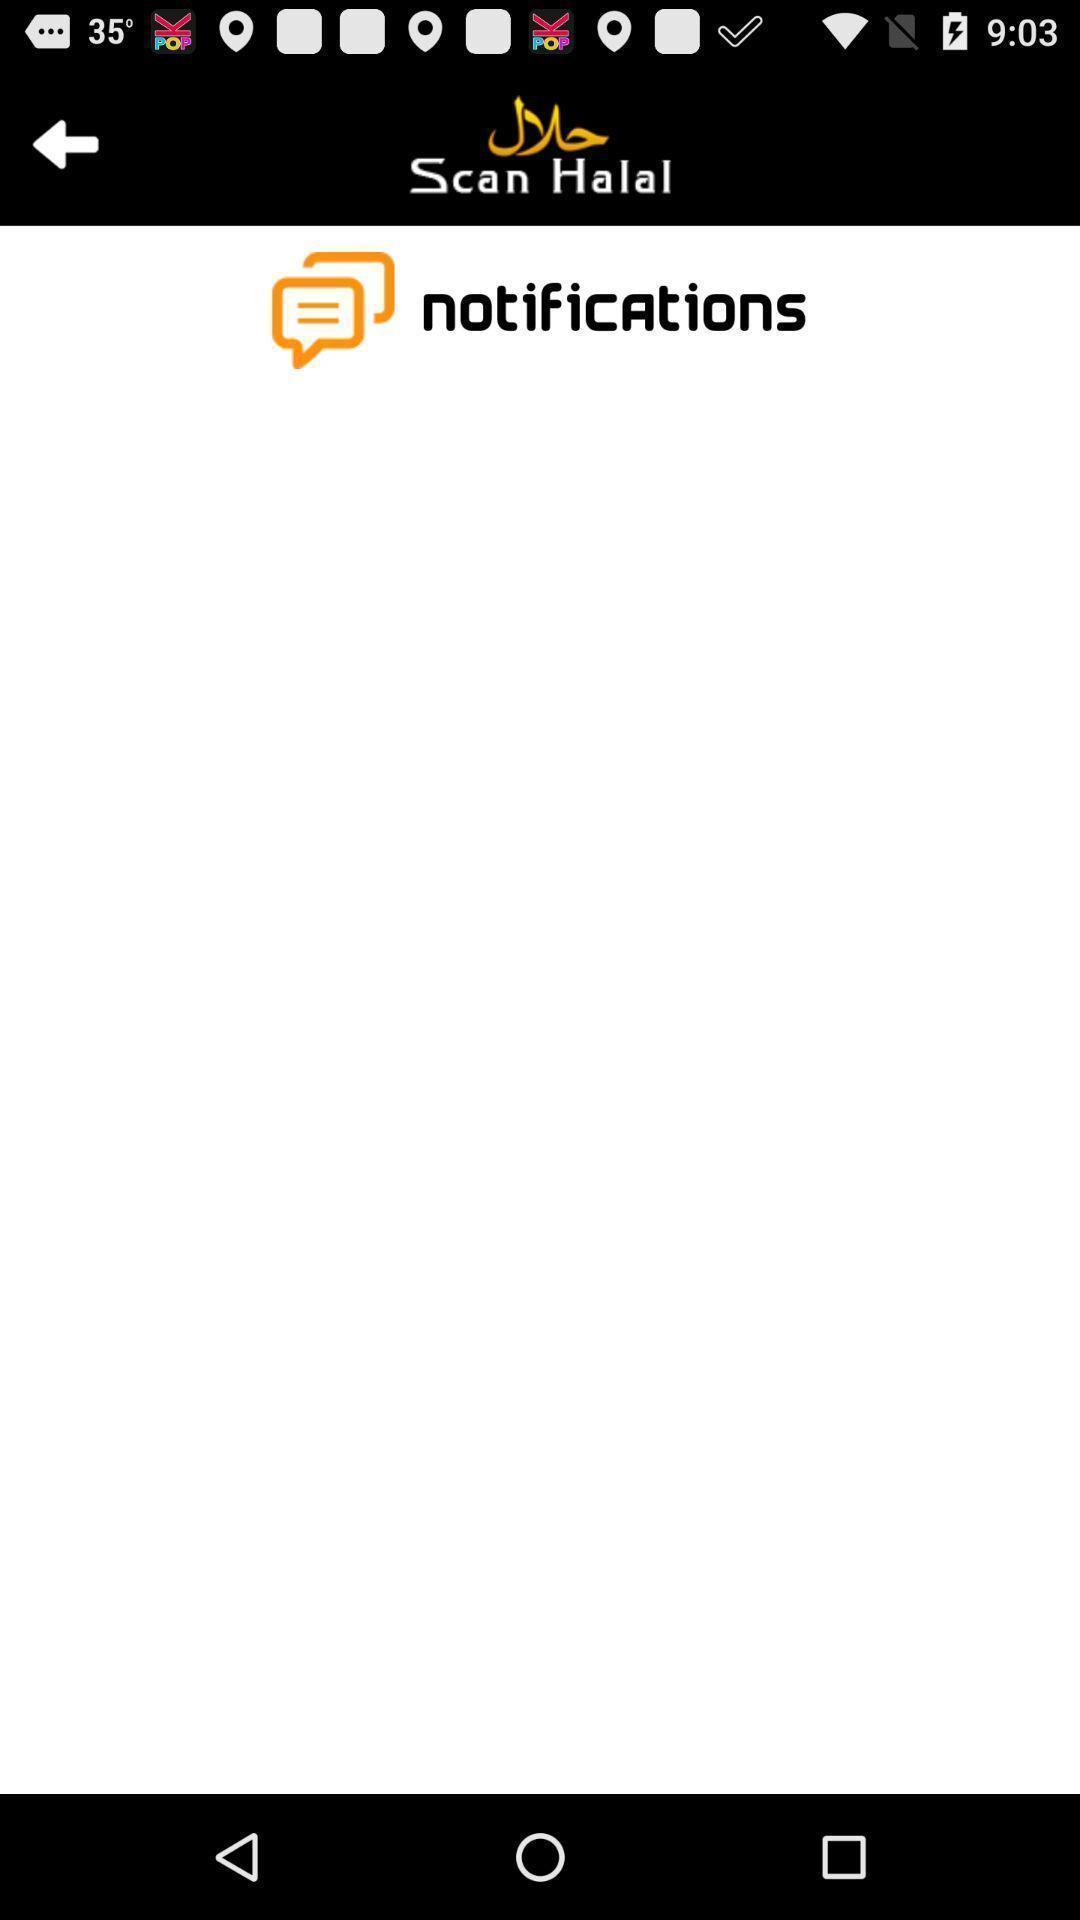Explain the elements present in this screenshot. Screen display notification page. 